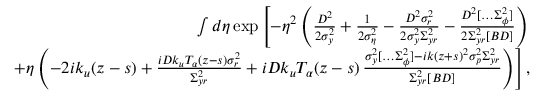Convert formula to latex. <formula><loc_0><loc_0><loc_500><loc_500>\begin{array} { r l r } & { \int d \eta \exp \left [ - \eta ^ { 2 } \left ( \frac { D ^ { 2 } } { 2 \sigma _ { y } ^ { 2 } } + \frac { 1 } { 2 \sigma _ { \eta } ^ { 2 } } - \frac { D ^ { 2 } \sigma _ { r } ^ { 2 } } { 2 \sigma _ { y } ^ { 2 } \Sigma _ { y r } ^ { 2 } } - \frac { D ^ { 2 } [ \hdots \Sigma _ { \phi } ^ { 2 } ] } { 2 \Sigma _ { y r } ^ { 2 } [ B D ] } \right ) } \\ & { \quad + \eta \left ( - 2 i k _ { u } ( z - s ) + \frac { i D k _ { u } T _ { \alpha } ( z - s ) \sigma _ { r } ^ { 2 } } { \Sigma _ { y r } ^ { 2 } } + i D k _ { u } T _ { \alpha } ( z - s ) \, \frac { \sigma _ { y } ^ { 2 } [ \hdots \Sigma _ { \phi } ^ { 2 } ] - i k ( z + s ) ^ { 2 } \sigma _ { p } ^ { 2 } \Sigma _ { y r } ^ { 2 } } { \Sigma _ { y r } ^ { 2 } [ B D ] } \right ) \right ] , } \end{array}</formula> 